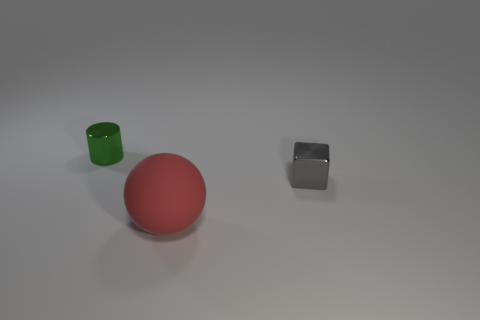What size is the green metallic cylinder on the left side of the tiny gray cube?
Your answer should be compact. Small. Are there any other big objects that have the same material as the gray object?
Offer a terse response. No. How many other green objects have the same shape as the big rubber thing?
Offer a very short reply. 0. There is a small metallic thing that is to the left of the object in front of the tiny thing that is on the right side of the red object; what shape is it?
Provide a succinct answer. Cylinder. What material is the thing that is both in front of the green cylinder and to the left of the gray block?
Your response must be concise. Rubber. There is a metal object right of the green shiny object; does it have the same size as the large red thing?
Offer a terse response. No. Is there any other thing that has the same size as the red thing?
Your answer should be very brief. No. Is the number of metallic objects behind the small gray metallic block greater than the number of gray metallic things that are to the left of the big red ball?
Provide a short and direct response. Yes. What is the color of the small object behind the metal thing right of the cylinder that is left of the red ball?
Keep it short and to the point. Green. Is the color of the metal object that is to the right of the tiny green object the same as the large object?
Your answer should be compact. No. 